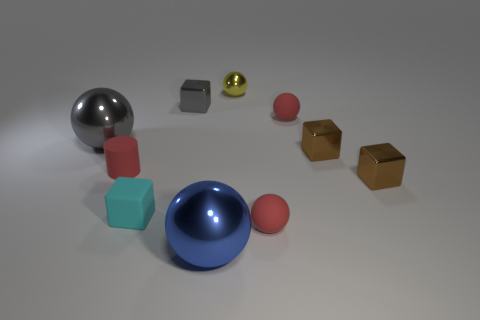What color is the small matte cube?
Offer a very short reply. Cyan. There is a object that is both behind the tiny cylinder and to the left of the cyan block; what is its material?
Ensure brevity in your answer.  Metal. Is there a tiny matte cylinder that is on the right side of the shiny thing that is behind the metal block that is behind the big gray metallic thing?
Offer a very short reply. No. There is a big gray metallic ball; are there any rubber cubes to the left of it?
Keep it short and to the point. No. What number of other things are the same shape as the small gray thing?
Your response must be concise. 3. There is another metallic ball that is the same size as the gray metallic ball; what color is it?
Give a very brief answer. Blue. Is the number of small red objects left of the big blue metal ball less than the number of yellow balls on the left side of the gray metallic block?
Provide a short and direct response. No. How many large gray objects are on the right side of the tiny red ball behind the gray thing to the left of the tiny red cylinder?
Provide a succinct answer. 0. What is the size of the gray object that is the same shape as the cyan rubber thing?
Provide a short and direct response. Small. Is there anything else that is the same size as the matte cylinder?
Make the answer very short. Yes. 